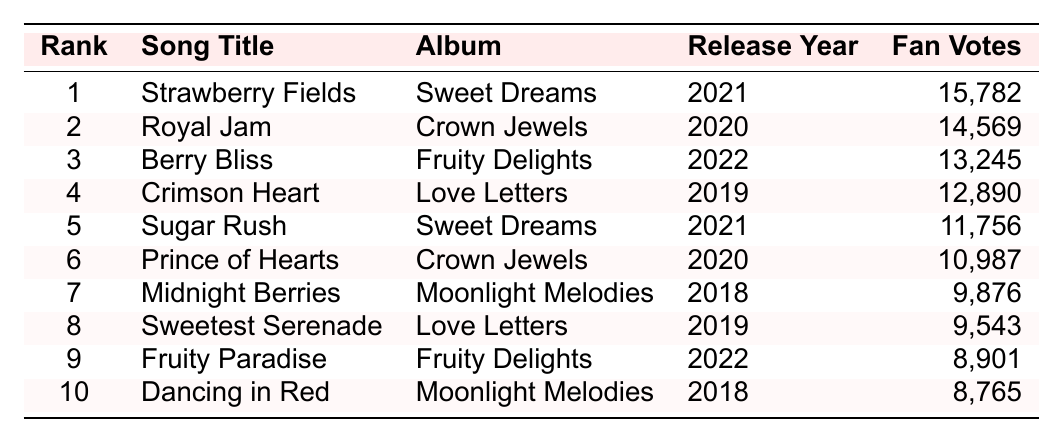What is the song with the highest number of fan votes? The song "Strawberry Fields" has the highest fan votes listed in the table with a total of 15,782.
Answer: Strawberry Fields Which album features the song "Berry Bliss"? The song "Berry Bliss" is from the album "Fruity Delights," as indicated in the table.
Answer: Fruity Delights What is the release year of the song "Royal Jam"? The release year of "Royal Jam" is 2020, as shown in the corresponding row of the table.
Answer: 2020 How many fan votes did "Sugar Rush" receive? The number of fan votes for "Sugar Rush" is specified in the table as 11,756.
Answer: 11,756 Which song title ranks fifth? According to the ranking in the table, the song in the fifth position is "Sugar Rush."
Answer: Sugar Rush What is the average number of fan votes for all songs listed? To find the average, we add all the fan votes: (15,782 + 14,569 + 13,245 + 12,890 + 11,756 + 10,987 + 9,876 + 9,543 + 8,901 + 8,765) =  104,764. There are 10 songs, so the average is 104,764 / 10 = 10,476.4.
Answer: 10,476.4 Which two songs have the closest number of fan votes? Comparing the fan votes, "Crimson Heart" (12,890) and "Sugar Rush" (11,756) have the smallest difference of 1,134 votes.
Answer: Crimson Heart and Sugar Rush Is "Midnight Berries" from the same album as "Dancing in Red"? No, "Midnight Berries" is from the album "Moonlight Melodies" while "Dancing in Red" is also from "Moonlight Melodies," so they are from the same album.
Answer: Yes How many more votes does "Strawberry Fields" have compared to "Fruity Paradise"? "Strawberry Fields" has 15,782 votes and "Fruity Paradise" has 8,901 votes. The difference is 15,782 - 8,901 = 6,881.
Answer: 6,881 What is the total number of fan votes for songs released in 2021? The songs released in 2021 are "Strawberry Fields" (15,782) and "Sugar Rush" (11,756). Summing these gives 15,782 + 11,756 = 27,538.
Answer: 27,538 